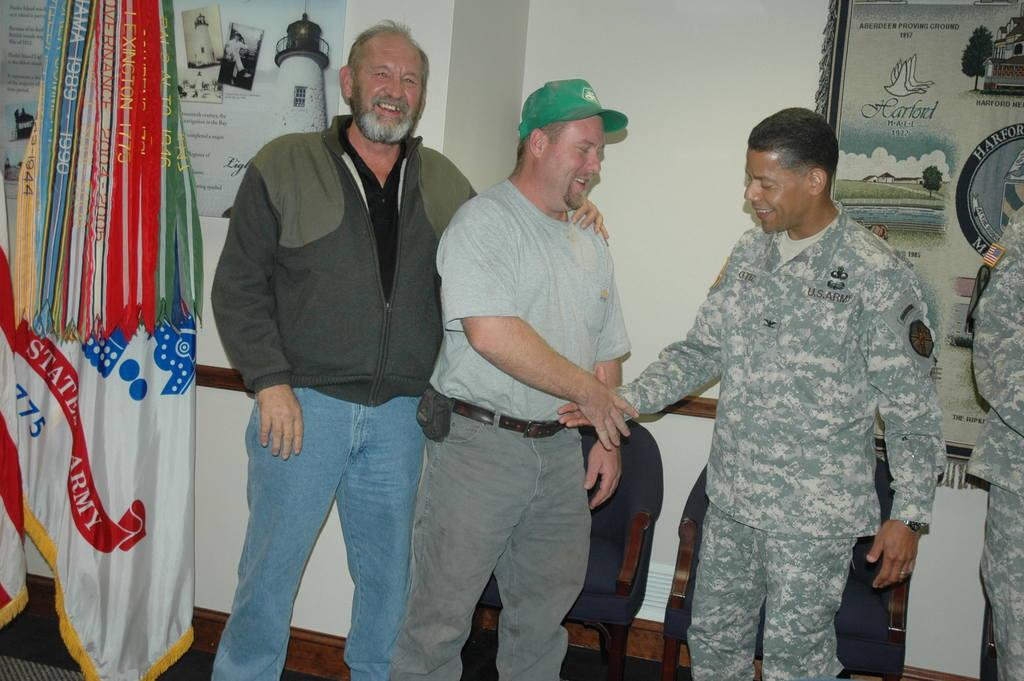What is the main subject of the image? The main subject of the image is a group of men standing in the center. Where are the men standing? The men are standing on the floor. What can be seen on the left side of the image? There is a poster and a flag on the left side of the image. What is visible in the background of the image? There are chairs, a poster, and a wall in the background of the image. What is the opinion of the iron on the poster in the background? There is no iron present in the image, and therefore no opinion can be attributed to it. 